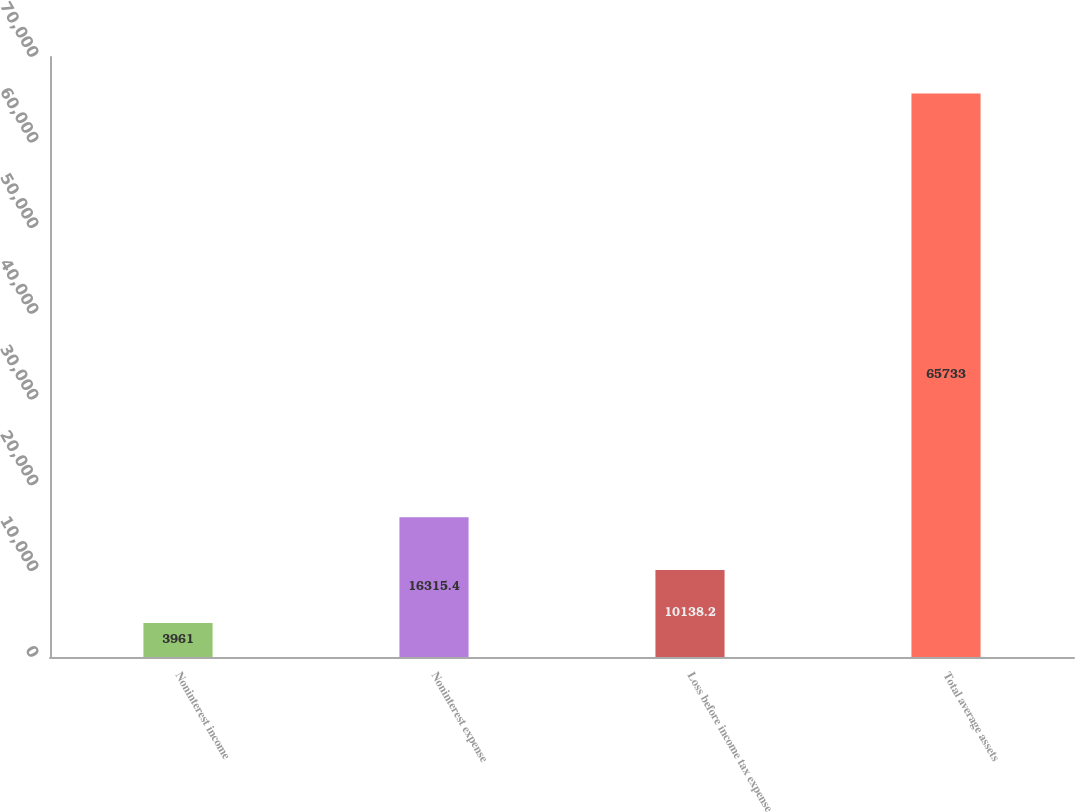Convert chart to OTSL. <chart><loc_0><loc_0><loc_500><loc_500><bar_chart><fcel>Noninterest income<fcel>Noninterest expense<fcel>Loss before income tax expense<fcel>Total average assets<nl><fcel>3961<fcel>16315.4<fcel>10138.2<fcel>65733<nl></chart> 